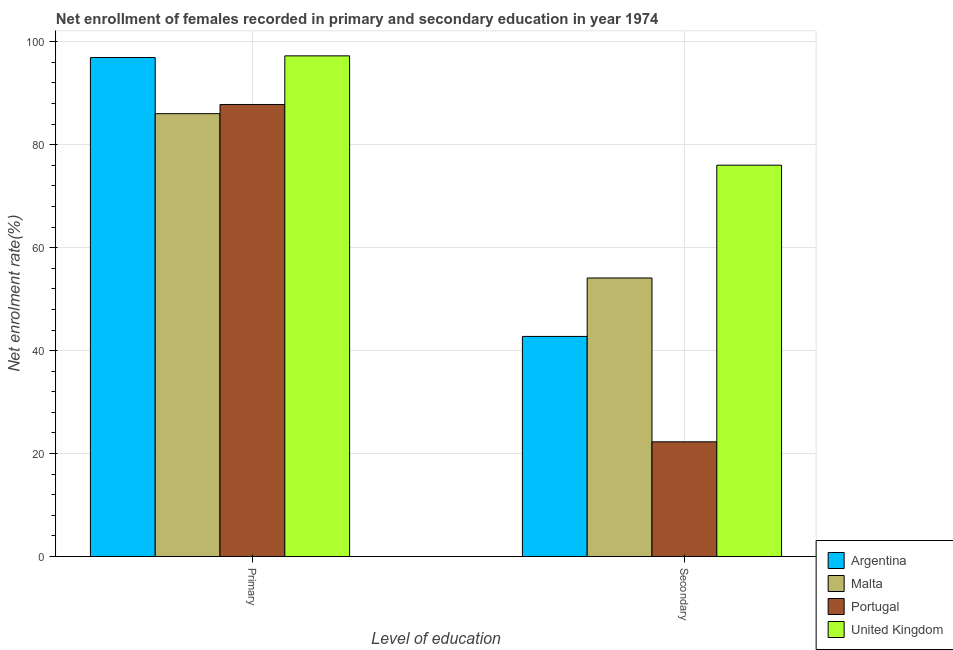How many different coloured bars are there?
Offer a terse response. 4. Are the number of bars on each tick of the X-axis equal?
Ensure brevity in your answer.  Yes. How many bars are there on the 1st tick from the right?
Offer a very short reply. 4. What is the label of the 1st group of bars from the left?
Your answer should be very brief. Primary. What is the enrollment rate in secondary education in Malta?
Offer a terse response. 54.12. Across all countries, what is the maximum enrollment rate in secondary education?
Ensure brevity in your answer.  76.03. Across all countries, what is the minimum enrollment rate in secondary education?
Offer a terse response. 22.29. In which country was the enrollment rate in primary education minimum?
Your response must be concise. Malta. What is the total enrollment rate in secondary education in the graph?
Your answer should be compact. 195.19. What is the difference between the enrollment rate in primary education in United Kingdom and that in Malta?
Offer a terse response. 11.23. What is the difference between the enrollment rate in primary education in Malta and the enrollment rate in secondary education in Portugal?
Provide a succinct answer. 63.76. What is the average enrollment rate in secondary education per country?
Ensure brevity in your answer.  48.8. What is the difference between the enrollment rate in secondary education and enrollment rate in primary education in United Kingdom?
Give a very brief answer. -21.24. What is the ratio of the enrollment rate in primary education in United Kingdom to that in Malta?
Make the answer very short. 1.13. Is the enrollment rate in primary education in United Kingdom less than that in Portugal?
Offer a terse response. No. In how many countries, is the enrollment rate in secondary education greater than the average enrollment rate in secondary education taken over all countries?
Give a very brief answer. 2. What does the 1st bar from the left in Primary represents?
Your response must be concise. Argentina. What does the 3rd bar from the right in Primary represents?
Provide a succinct answer. Malta. How many bars are there?
Make the answer very short. 8. Are all the bars in the graph horizontal?
Offer a terse response. No. How many countries are there in the graph?
Ensure brevity in your answer.  4. Are the values on the major ticks of Y-axis written in scientific E-notation?
Keep it short and to the point. No. Where does the legend appear in the graph?
Make the answer very short. Bottom right. What is the title of the graph?
Provide a short and direct response. Net enrollment of females recorded in primary and secondary education in year 1974. Does "Moldova" appear as one of the legend labels in the graph?
Ensure brevity in your answer.  No. What is the label or title of the X-axis?
Keep it short and to the point. Level of education. What is the label or title of the Y-axis?
Keep it short and to the point. Net enrolment rate(%). What is the Net enrolment rate(%) of Argentina in Primary?
Offer a very short reply. 96.94. What is the Net enrolment rate(%) of Malta in Primary?
Offer a very short reply. 86.04. What is the Net enrolment rate(%) in Portugal in Primary?
Keep it short and to the point. 87.83. What is the Net enrolment rate(%) of United Kingdom in Primary?
Provide a succinct answer. 97.27. What is the Net enrolment rate(%) in Argentina in Secondary?
Your response must be concise. 42.76. What is the Net enrolment rate(%) in Malta in Secondary?
Offer a very short reply. 54.12. What is the Net enrolment rate(%) of Portugal in Secondary?
Keep it short and to the point. 22.29. What is the Net enrolment rate(%) in United Kingdom in Secondary?
Your answer should be very brief. 76.03. Across all Level of education, what is the maximum Net enrolment rate(%) in Argentina?
Ensure brevity in your answer.  96.94. Across all Level of education, what is the maximum Net enrolment rate(%) in Malta?
Make the answer very short. 86.04. Across all Level of education, what is the maximum Net enrolment rate(%) of Portugal?
Your answer should be compact. 87.83. Across all Level of education, what is the maximum Net enrolment rate(%) in United Kingdom?
Your response must be concise. 97.27. Across all Level of education, what is the minimum Net enrolment rate(%) of Argentina?
Your answer should be very brief. 42.76. Across all Level of education, what is the minimum Net enrolment rate(%) in Malta?
Your answer should be compact. 54.12. Across all Level of education, what is the minimum Net enrolment rate(%) in Portugal?
Keep it short and to the point. 22.29. Across all Level of education, what is the minimum Net enrolment rate(%) of United Kingdom?
Make the answer very short. 76.03. What is the total Net enrolment rate(%) of Argentina in the graph?
Offer a very short reply. 139.7. What is the total Net enrolment rate(%) in Malta in the graph?
Your answer should be very brief. 140.16. What is the total Net enrolment rate(%) in Portugal in the graph?
Keep it short and to the point. 110.11. What is the total Net enrolment rate(%) of United Kingdom in the graph?
Make the answer very short. 173.3. What is the difference between the Net enrolment rate(%) in Argentina in Primary and that in Secondary?
Make the answer very short. 54.18. What is the difference between the Net enrolment rate(%) in Malta in Primary and that in Secondary?
Your response must be concise. 31.93. What is the difference between the Net enrolment rate(%) in Portugal in Primary and that in Secondary?
Give a very brief answer. 65.54. What is the difference between the Net enrolment rate(%) of United Kingdom in Primary and that in Secondary?
Ensure brevity in your answer.  21.24. What is the difference between the Net enrolment rate(%) of Argentina in Primary and the Net enrolment rate(%) of Malta in Secondary?
Provide a succinct answer. 42.83. What is the difference between the Net enrolment rate(%) in Argentina in Primary and the Net enrolment rate(%) in Portugal in Secondary?
Make the answer very short. 74.66. What is the difference between the Net enrolment rate(%) in Argentina in Primary and the Net enrolment rate(%) in United Kingdom in Secondary?
Offer a very short reply. 20.91. What is the difference between the Net enrolment rate(%) of Malta in Primary and the Net enrolment rate(%) of Portugal in Secondary?
Offer a terse response. 63.76. What is the difference between the Net enrolment rate(%) of Malta in Primary and the Net enrolment rate(%) of United Kingdom in Secondary?
Keep it short and to the point. 10.01. What is the difference between the Net enrolment rate(%) in Portugal in Primary and the Net enrolment rate(%) in United Kingdom in Secondary?
Your response must be concise. 11.8. What is the average Net enrolment rate(%) in Argentina per Level of education?
Keep it short and to the point. 69.85. What is the average Net enrolment rate(%) in Malta per Level of education?
Your response must be concise. 70.08. What is the average Net enrolment rate(%) of Portugal per Level of education?
Keep it short and to the point. 55.06. What is the average Net enrolment rate(%) in United Kingdom per Level of education?
Ensure brevity in your answer.  86.65. What is the difference between the Net enrolment rate(%) in Argentina and Net enrolment rate(%) in Malta in Primary?
Your response must be concise. 10.9. What is the difference between the Net enrolment rate(%) in Argentina and Net enrolment rate(%) in Portugal in Primary?
Provide a succinct answer. 9.12. What is the difference between the Net enrolment rate(%) in Argentina and Net enrolment rate(%) in United Kingdom in Primary?
Your answer should be compact. -0.33. What is the difference between the Net enrolment rate(%) in Malta and Net enrolment rate(%) in Portugal in Primary?
Provide a short and direct response. -1.78. What is the difference between the Net enrolment rate(%) in Malta and Net enrolment rate(%) in United Kingdom in Primary?
Provide a succinct answer. -11.23. What is the difference between the Net enrolment rate(%) of Portugal and Net enrolment rate(%) of United Kingdom in Primary?
Keep it short and to the point. -9.45. What is the difference between the Net enrolment rate(%) of Argentina and Net enrolment rate(%) of Malta in Secondary?
Your answer should be compact. -11.36. What is the difference between the Net enrolment rate(%) in Argentina and Net enrolment rate(%) in Portugal in Secondary?
Your answer should be compact. 20.48. What is the difference between the Net enrolment rate(%) in Argentina and Net enrolment rate(%) in United Kingdom in Secondary?
Offer a terse response. -33.27. What is the difference between the Net enrolment rate(%) in Malta and Net enrolment rate(%) in Portugal in Secondary?
Provide a succinct answer. 31.83. What is the difference between the Net enrolment rate(%) of Malta and Net enrolment rate(%) of United Kingdom in Secondary?
Your answer should be very brief. -21.91. What is the difference between the Net enrolment rate(%) in Portugal and Net enrolment rate(%) in United Kingdom in Secondary?
Make the answer very short. -53.74. What is the ratio of the Net enrolment rate(%) in Argentina in Primary to that in Secondary?
Provide a short and direct response. 2.27. What is the ratio of the Net enrolment rate(%) in Malta in Primary to that in Secondary?
Offer a very short reply. 1.59. What is the ratio of the Net enrolment rate(%) in Portugal in Primary to that in Secondary?
Offer a very short reply. 3.94. What is the ratio of the Net enrolment rate(%) in United Kingdom in Primary to that in Secondary?
Provide a succinct answer. 1.28. What is the difference between the highest and the second highest Net enrolment rate(%) in Argentina?
Your answer should be compact. 54.18. What is the difference between the highest and the second highest Net enrolment rate(%) in Malta?
Your answer should be very brief. 31.93. What is the difference between the highest and the second highest Net enrolment rate(%) of Portugal?
Ensure brevity in your answer.  65.54. What is the difference between the highest and the second highest Net enrolment rate(%) in United Kingdom?
Provide a succinct answer. 21.24. What is the difference between the highest and the lowest Net enrolment rate(%) in Argentina?
Offer a terse response. 54.18. What is the difference between the highest and the lowest Net enrolment rate(%) in Malta?
Your answer should be very brief. 31.93. What is the difference between the highest and the lowest Net enrolment rate(%) in Portugal?
Keep it short and to the point. 65.54. What is the difference between the highest and the lowest Net enrolment rate(%) of United Kingdom?
Ensure brevity in your answer.  21.24. 